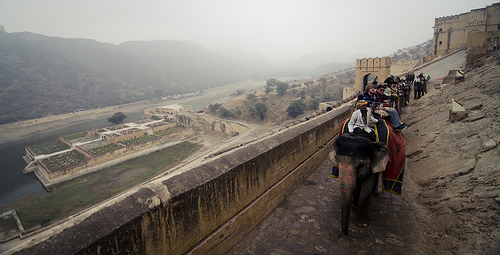Please provide the bounding box coordinate of the region this sentence describes: object on the ground. The coordinates [0.83, 0.41, 0.97, 0.54] mark the presence of an object on the ground, likely a piece of luggage or similar item, positioned on the dusty path. 